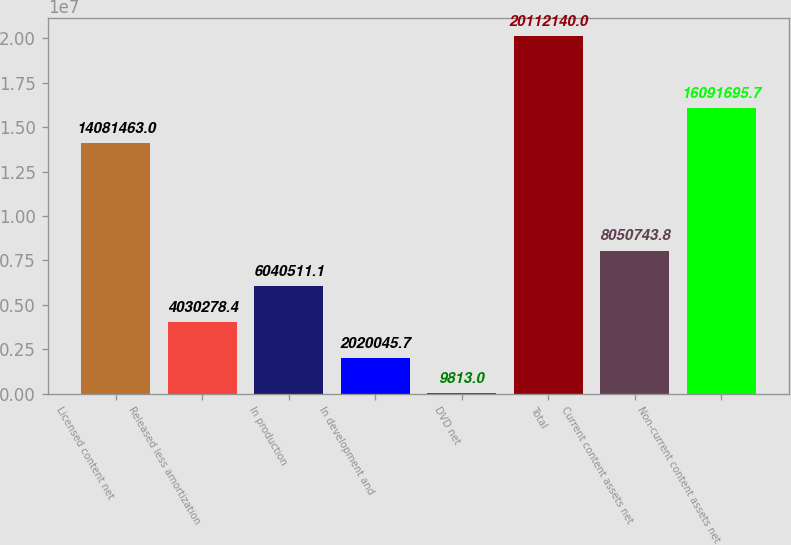Convert chart. <chart><loc_0><loc_0><loc_500><loc_500><bar_chart><fcel>Licensed content net<fcel>Released less amortization<fcel>In production<fcel>In development and<fcel>DVD net<fcel>Total<fcel>Current content assets net<fcel>Non-current content assets net<nl><fcel>1.40815e+07<fcel>4.03028e+06<fcel>6.04051e+06<fcel>2.02005e+06<fcel>9813<fcel>2.01121e+07<fcel>8.05074e+06<fcel>1.60917e+07<nl></chart> 